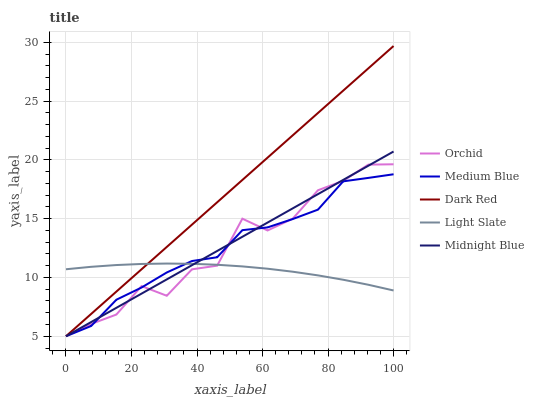Does Medium Blue have the minimum area under the curve?
Answer yes or no. No. Does Medium Blue have the maximum area under the curve?
Answer yes or no. No. Is Dark Red the smoothest?
Answer yes or no. No. Is Dark Red the roughest?
Answer yes or no. No. Does Medium Blue have the highest value?
Answer yes or no. No. 